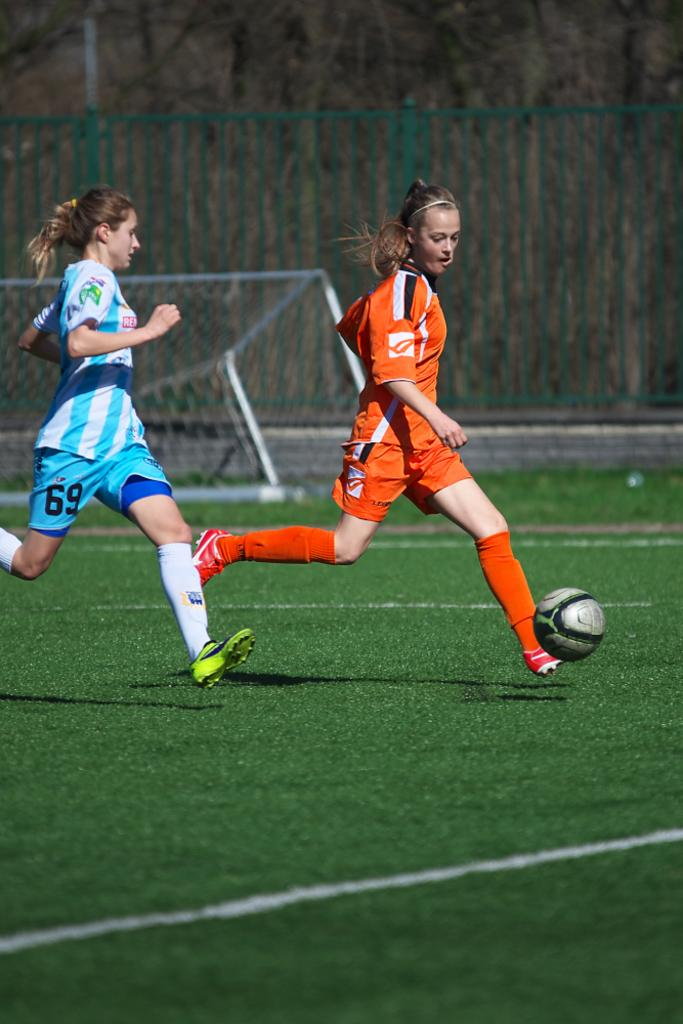<image>
Share a concise interpretation of the image provided. The soccer player in blue wears the number 69. 